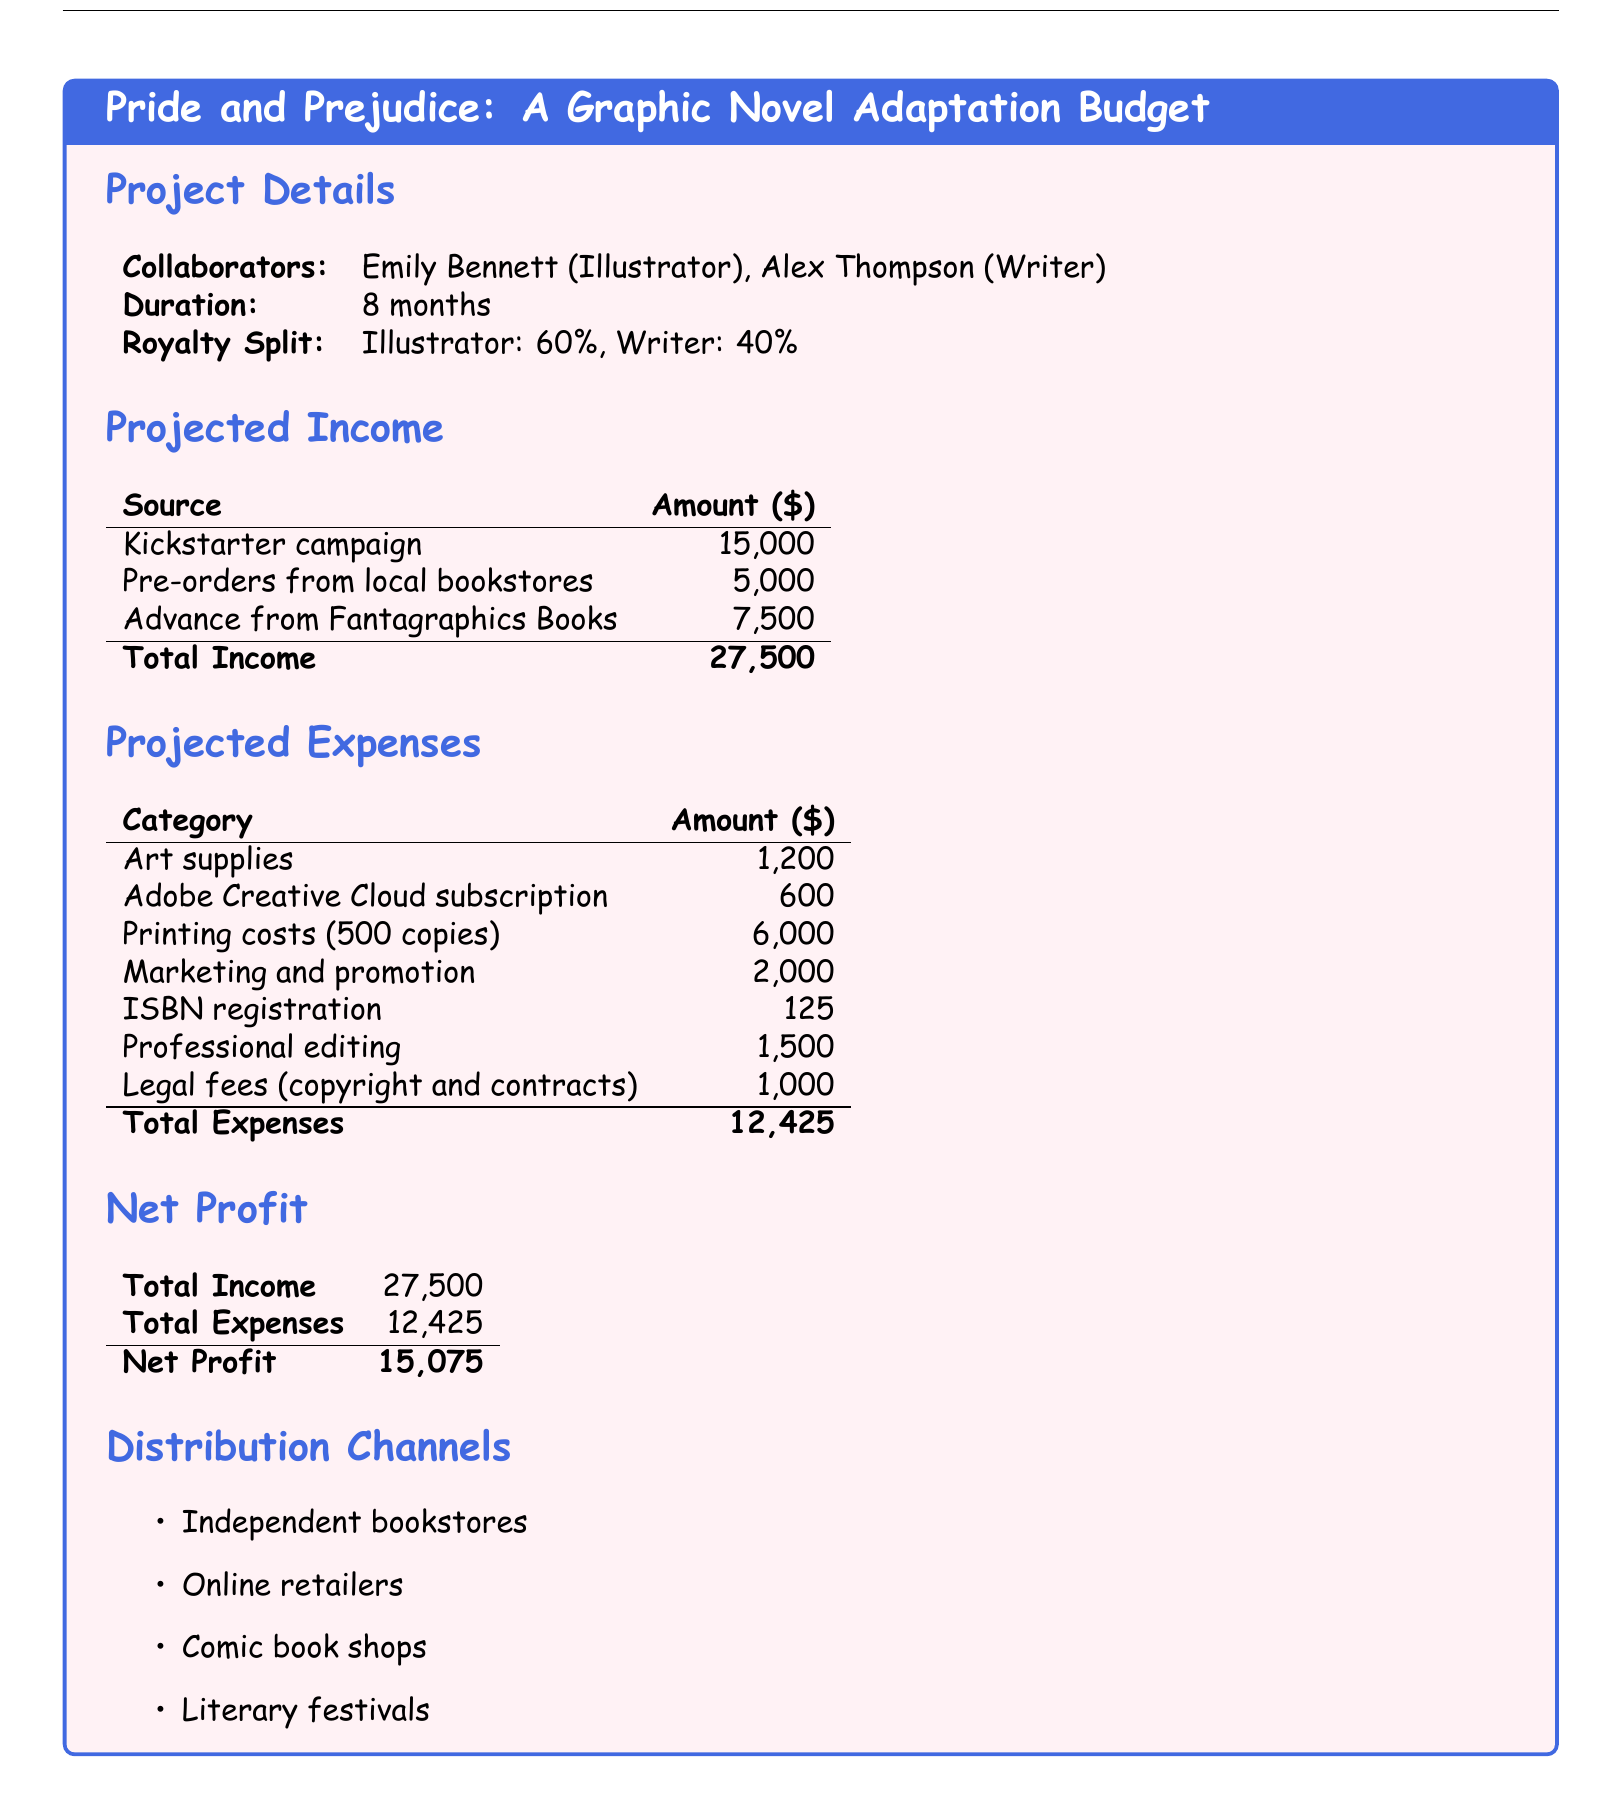What are the names of the collaborators? The document lists the names of the collaborators as Emily Bennett and Alex Thompson.
Answer: Emily Bennett, Alex Thompson What is the total income projected for the project? The total income is provided as the sum of all income sources listed in the document.
Answer: 27,500 How much will the illustrator receive from royalties? The illustrator's share is stated as a percentage of the total income within the document.
Answer: 60% What is the total amount set for marketing and promotion? The document specifies the amount allocated for marketing and promotion under projected expenses.
Answer: 2,000 What is the duration of the project? The duration is explicitly mentioned in the project details section of the document.
Answer: 8 months What is the total expense for printing costs? The expenses for printing costs are clearly indicated in the provided expense table.
Answer: 6,000 What is the net profit from the project? The net profit is calculated by subtracting total expenses from total income, as shown in the document.
Answer: 15,075 What category has the highest expense amount? The document lists the expenses, and one can see which category has the largest amount.
Answer: Printing costs In which channels will the comic be distributed? The distribution channels are listed as items in the document.
Answer: Independent bookstores, Online retailers, Comic book shops, Literary festivals 